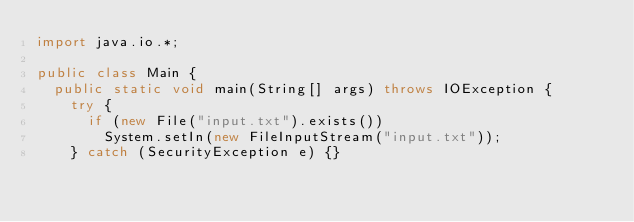Convert code to text. <code><loc_0><loc_0><loc_500><loc_500><_Java_>import java.io.*;

public class Main {
	public static void main(String[] args) throws IOException {
		try {
			if (new File("input.txt").exists())
				System.setIn(new FileInputStream("input.txt"));
		} catch (SecurityException e) {}
		</code> 